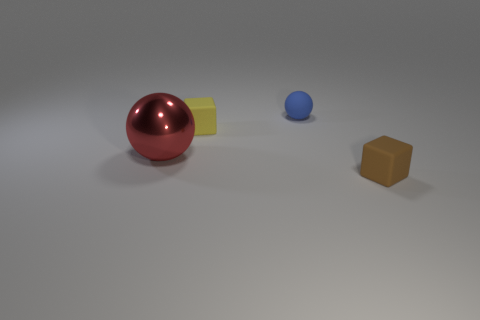Add 3 tiny brown balls. How many objects exist? 7 Subtract 0 blue cubes. How many objects are left? 4 Subtract all purple cubes. Subtract all purple spheres. How many cubes are left? 2 Subtract all purple cylinders. How many green blocks are left? 0 Subtract all big cyan matte cubes. Subtract all small yellow blocks. How many objects are left? 3 Add 1 matte spheres. How many matte spheres are left? 2 Add 2 cubes. How many cubes exist? 4 